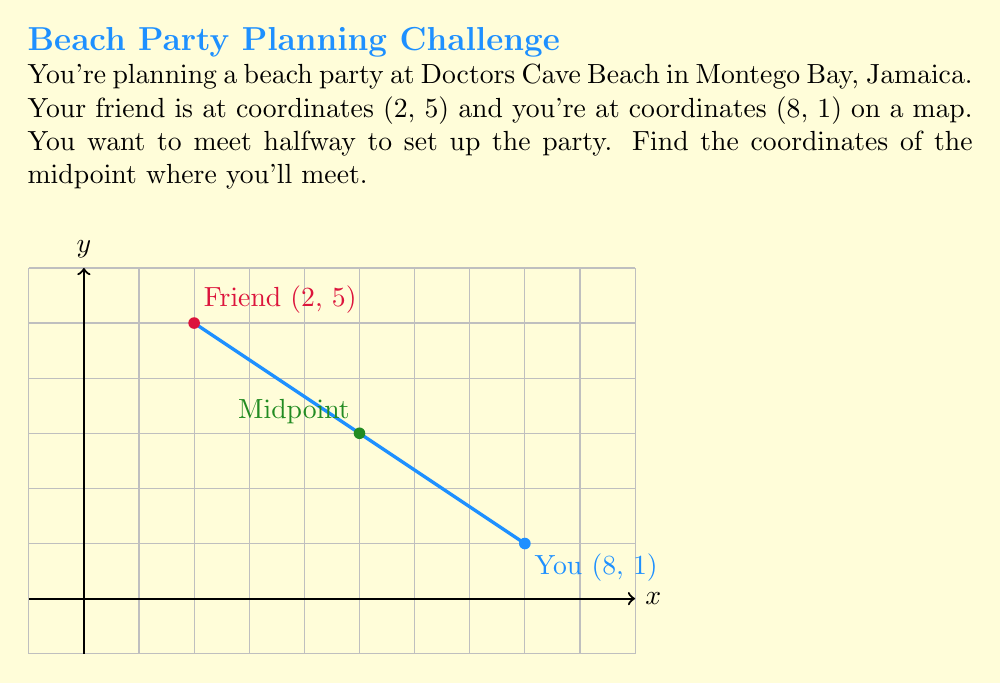Solve this math problem. To find the midpoint of a line segment, we use the midpoint formula:

$$ \text{Midpoint} = \left(\frac{x_1 + x_2}{2}, \frac{y_1 + y_2}{2}\right) $$

Where $(x_1, y_1)$ and $(x_2, y_2)$ are the coordinates of the two endpoints.

Given:
- Friend's coordinates: $(x_1, y_1) = (2, 5)$
- Your coordinates: $(x_2, y_2) = (8, 1)$

Step 1: Calculate the x-coordinate of the midpoint:
$$ x = \frac{x_1 + x_2}{2} = \frac{2 + 8}{2} = \frac{10}{2} = 5 $$

Step 2: Calculate the y-coordinate of the midpoint:
$$ y = \frac{y_1 + y_2}{2} = \frac{5 + 1}{2} = \frac{6}{2} = 3 $$

Therefore, the midpoint coordinates are (5, 3).
Answer: (5, 3) 